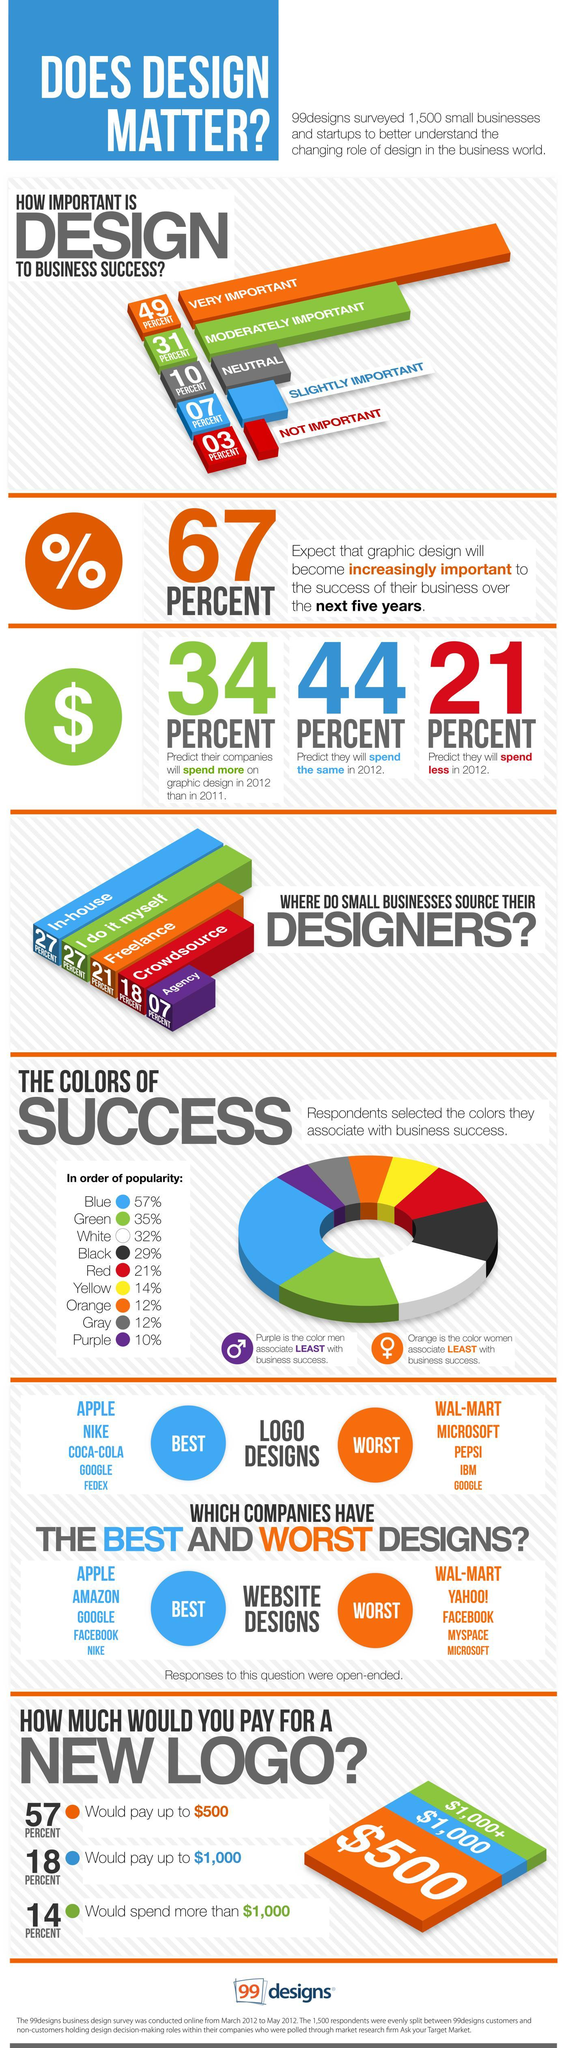What percentage of respondents predict that they will spend less in graphic design in 2012 as per the survey?
Answer the question with a short phrase. 21 PERCENT What percentage of respondents think that design is moderately important to business success according to the survey? 31 PERCENT What percentage of respondents predict that they will spend the same in graphic design in 2012 as per the survey? 44 PERCENT What percentage of respondents think that design is not at all important to business success according to the survey? 03 PERCENT What does majority of respondents think about the role of design to business success as per the survey? VERY IMPORTANT What percent of respondents spend more than $1,000 for a new logo design according to the survey? 14 PERCENT 